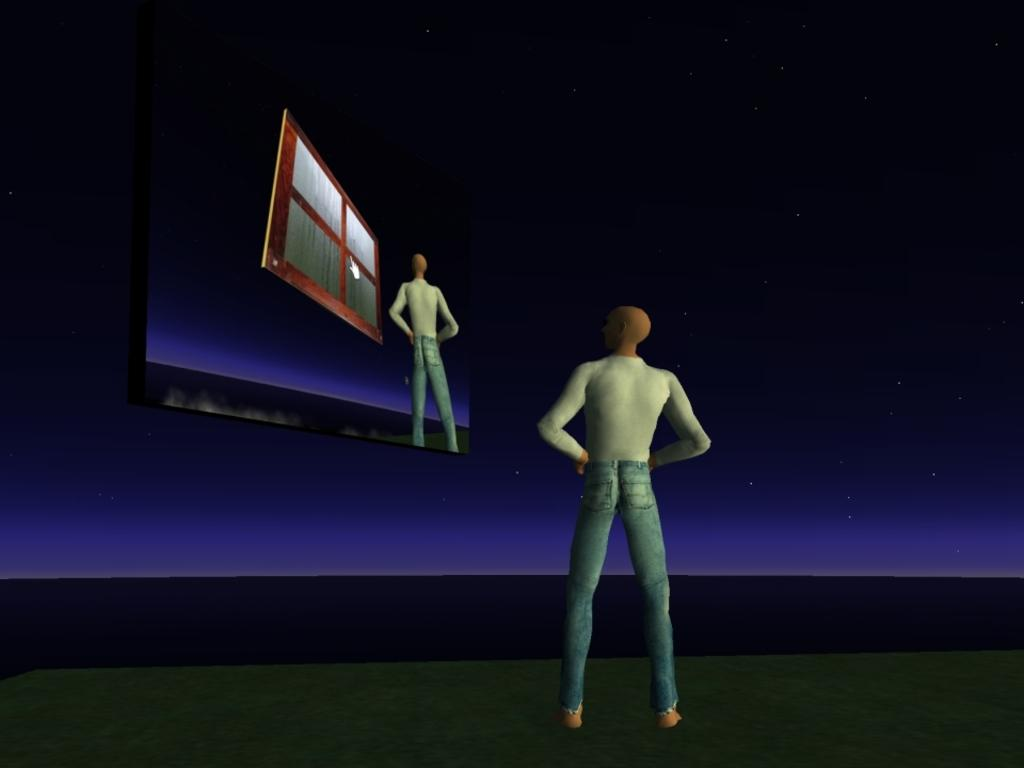What type of image is being described? The image is animated. Can you describe the man in the image? There is a man standing in the image. What is present in the image besides the man? There is a screen in the image. What can be seen on the screen? On the screen, there is a man and a window. How would you describe the background of the image? The background of the image is dark with stars. What type of vegetable is being held by the governor in the image? There is no governor or vegetable present in the image. Can you tell me how many fangs the man on the screen has? There is no mention of fangs or any creature with fangs in the image. 